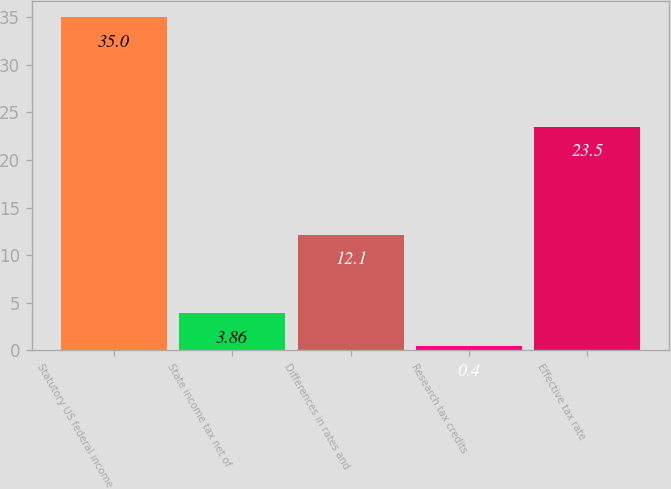<chart> <loc_0><loc_0><loc_500><loc_500><bar_chart><fcel>Statutory US federal income<fcel>State income tax net of<fcel>Differences in rates and<fcel>Research tax credits<fcel>Effective tax rate<nl><fcel>35<fcel>3.86<fcel>12.1<fcel>0.4<fcel>23.5<nl></chart> 